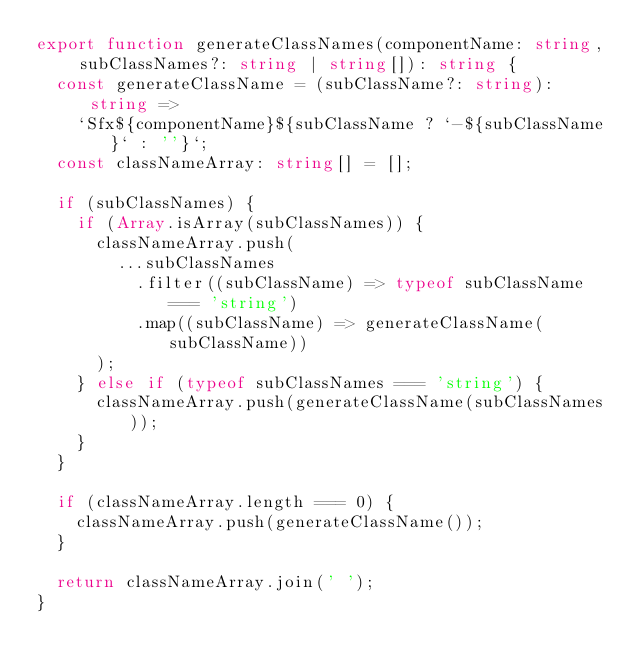<code> <loc_0><loc_0><loc_500><loc_500><_TypeScript_>export function generateClassNames(componentName: string, subClassNames?: string | string[]): string {
  const generateClassName = (subClassName?: string): string =>
    `Sfx${componentName}${subClassName ? `-${subClassName}` : ''}`;
  const classNameArray: string[] = [];

  if (subClassNames) {
    if (Array.isArray(subClassNames)) {
      classNameArray.push(
        ...subClassNames
          .filter((subClassName) => typeof subClassName === 'string')
          .map((subClassName) => generateClassName(subClassName))
      );
    } else if (typeof subClassNames === 'string') {
      classNameArray.push(generateClassName(subClassNames));
    }
  }

  if (classNameArray.length === 0) {
    classNameArray.push(generateClassName());
  }

  return classNameArray.join(' ');
}
</code> 